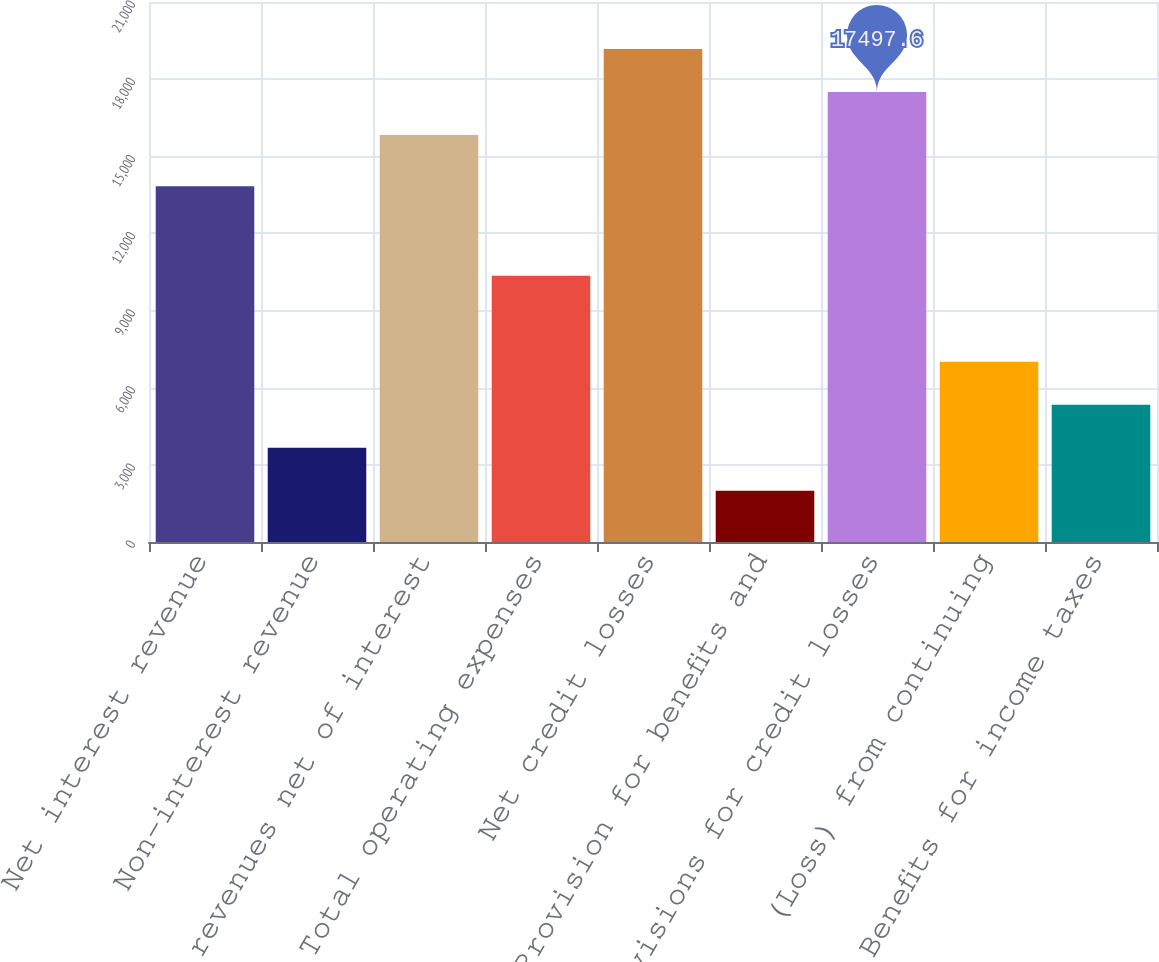Convert chart. <chart><loc_0><loc_0><loc_500><loc_500><bar_chart><fcel>Net interest revenue<fcel>Non-interest revenue<fcel>Total revenues net of interest<fcel>Total operating expenses<fcel>Net credit losses<fcel>Provision for benefits and<fcel>Provisions for credit losses<fcel>(Loss) from continuing<fcel>Benefits for income taxes<nl><fcel>13831<fcel>3667.2<fcel>15826<fcel>10353.6<fcel>19169.2<fcel>1995.6<fcel>17497.6<fcel>7010.4<fcel>5338.8<nl></chart> 